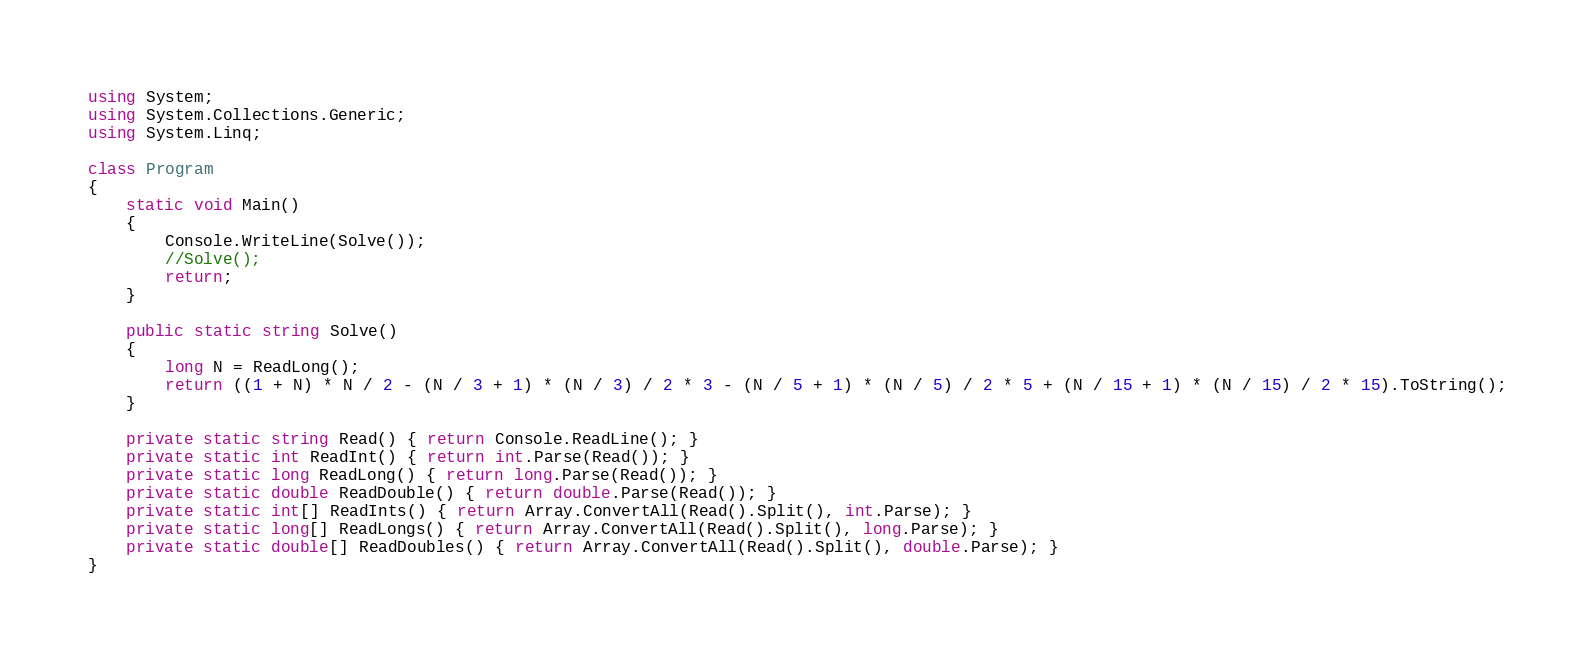<code> <loc_0><loc_0><loc_500><loc_500><_C#_>using System;
using System.Collections.Generic;
using System.Linq;

class Program
{
    static void Main()
    {
        Console.WriteLine(Solve());
        //Solve();
        return;
    }

    public static string Solve()
    {
        long N = ReadLong();
        return ((1 + N) * N / 2 - (N / 3 + 1) * (N / 3) / 2 * 3 - (N / 5 + 1) * (N / 5) / 2 * 5 + (N / 15 + 1) * (N / 15) / 2 * 15).ToString();
    }

    private static string Read() { return Console.ReadLine(); }
    private static int ReadInt() { return int.Parse(Read()); }
    private static long ReadLong() { return long.Parse(Read()); }
    private static double ReadDouble() { return double.Parse(Read()); }
    private static int[] ReadInts() { return Array.ConvertAll(Read().Split(), int.Parse); }
    private static long[] ReadLongs() { return Array.ConvertAll(Read().Split(), long.Parse); }
    private static double[] ReadDoubles() { return Array.ConvertAll(Read().Split(), double.Parse); }
}
</code> 